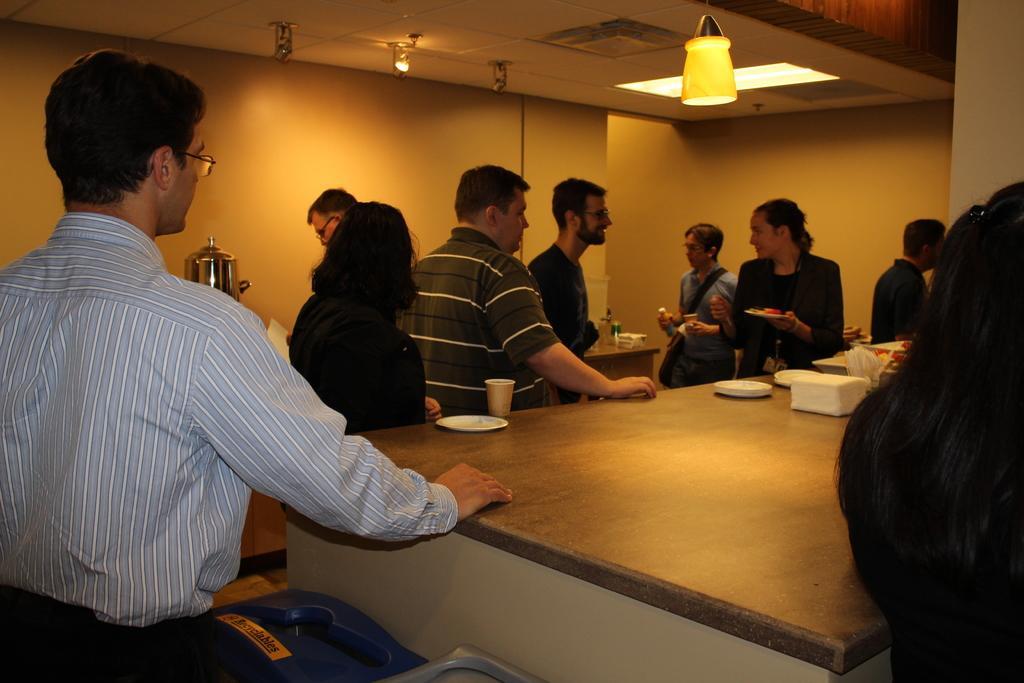Can you describe this image briefly? Here we see a group of people standing and two of them are speaking to each other. 